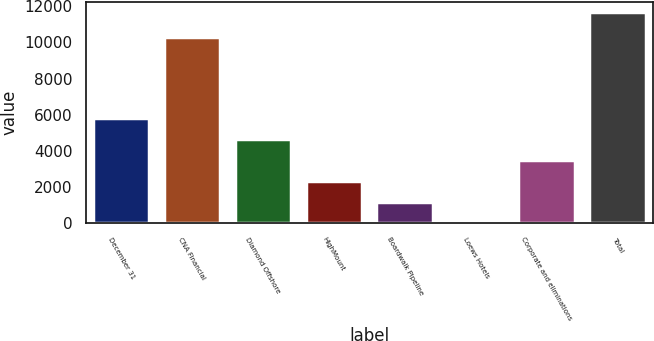Convert chart. <chart><loc_0><loc_0><loc_500><loc_500><bar_chart><fcel>December 31<fcel>CNA Financial<fcel>Diamond Offshore<fcel>HighMount<fcel>Boardwalk Pipeline<fcel>Loews Hotels<fcel>Corporate and eliminations<fcel>Total<nl><fcel>5847.5<fcel>10290<fcel>4682.6<fcel>2352.8<fcel>1187.9<fcel>23<fcel>3517.7<fcel>11672<nl></chart> 